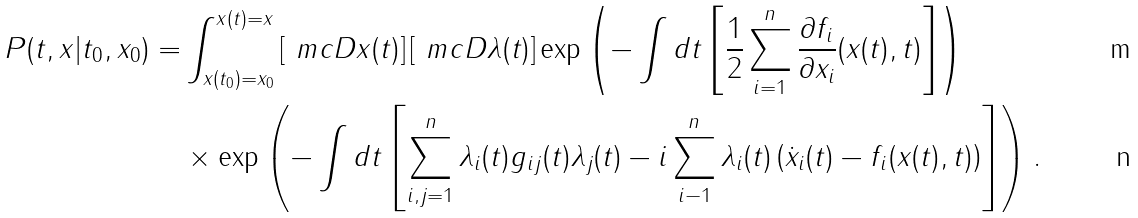Convert formula to latex. <formula><loc_0><loc_0><loc_500><loc_500>P ( t , x | t _ { 0 } , x _ { 0 } ) = & \int _ { x ( t _ { 0 } ) = x _ { 0 } } ^ { x ( t ) = x } \left [ \ m c { D } x ( t ) \right ] \left [ \ m c { D } \lambda ( t ) \right ] \exp \left ( - \int d t \left [ \frac { 1 } { 2 } \sum _ { i = 1 } ^ { n } \frac { \partial f _ { i } } { \partial x _ { i } } ( x ( t ) , t ) \right ] \right ) \\ & \times \exp \left ( - \int d t \left [ \sum _ { i , j = 1 } ^ { n } \lambda _ { i } ( t ) g _ { i j } ( t ) \lambda _ { j } ( t ) - i \sum _ { i - 1 } ^ { n } \lambda _ { i } ( t ) \left ( \dot { x } _ { i } ( t ) - f _ { i } ( x ( t ) , t ) \right ) \right ] \right ) .</formula> 